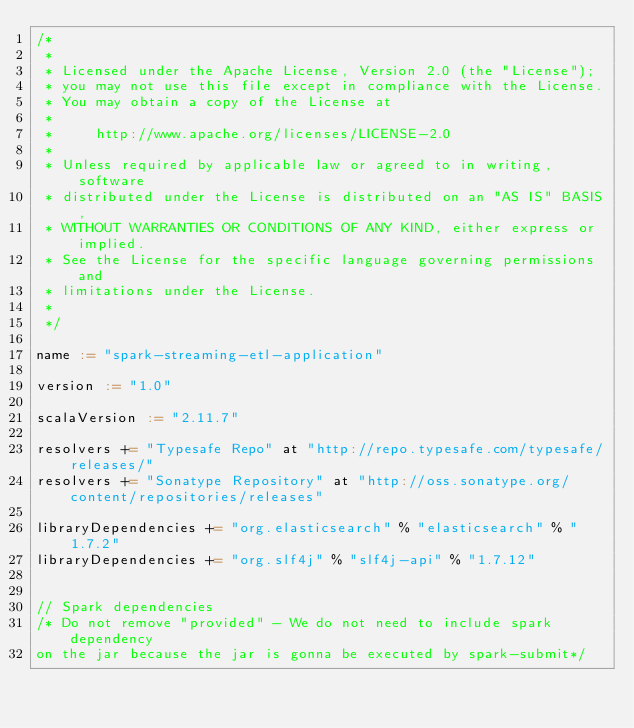<code> <loc_0><loc_0><loc_500><loc_500><_Scala_>/*
 *
 * Licensed under the Apache License, Version 2.0 (the "License");
 * you may not use this file except in compliance with the License.
 * You may obtain a copy of the License at
 *
 *     http://www.apache.org/licenses/LICENSE-2.0
 *
 * Unless required by applicable law or agreed to in writing, software
 * distributed under the License is distributed on an "AS IS" BASIS,
 * WITHOUT WARRANTIES OR CONDITIONS OF ANY KIND, either express or implied.
 * See the License for the specific language governing permissions and
 * limitations under the License.
 *
 */

name := "spark-streaming-etl-application"

version := "1.0"

scalaVersion := "2.11.7"

resolvers += "Typesafe Repo" at "http://repo.typesafe.com/typesafe/releases/"
resolvers += "Sonatype Repository" at "http://oss.sonatype.org/content/repositories/releases"

libraryDependencies += "org.elasticsearch" % "elasticsearch" % "1.7.2"
libraryDependencies += "org.slf4j" % "slf4j-api" % "1.7.12"


// Spark dependencies
/* Do not remove "provided" - We do not need to include spark dependency
on the jar because the jar is gonna be executed by spark-submit*/</code> 